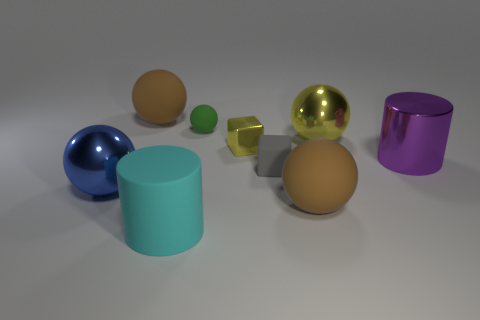What is the shape of the small gray thing?
Provide a short and direct response. Cube. Are there fewer large purple metallic cylinders than blue cylinders?
Offer a very short reply. No. Are there any other things that are the same size as the blue thing?
Your answer should be compact. Yes. There is another big object that is the same shape as the big cyan rubber thing; what is it made of?
Your answer should be very brief. Metal. Are there more rubber things than tiny cylinders?
Keep it short and to the point. Yes. How many other things are the same color as the small metallic block?
Offer a very short reply. 1. Are the big yellow sphere and the cylinder in front of the blue sphere made of the same material?
Ensure brevity in your answer.  No. How many large metal objects are to the left of the large matte object behind the brown thing right of the cyan rubber cylinder?
Provide a succinct answer. 1. Are there fewer tiny objects to the right of the gray block than big purple cylinders behind the big purple cylinder?
Offer a terse response. No. How many other things are the same material as the yellow block?
Offer a very short reply. 3. 